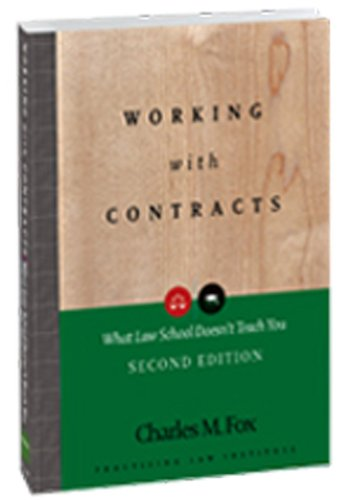Who wrote this book? This book, showcasing a plain yet compelling cover, was penned by Charles M. Fox, a knowledgeable figure in the field of law. 